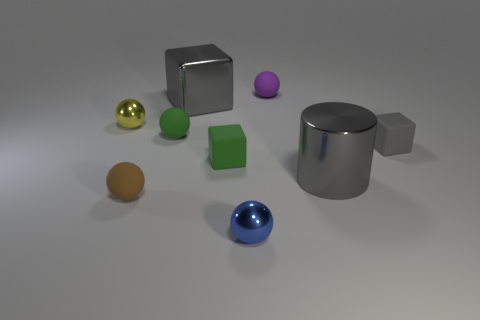Subtract all large shiny blocks. How many blocks are left? 2 Subtract 0 red spheres. How many objects are left? 9 Subtract all cylinders. How many objects are left? 8 Subtract 2 cubes. How many cubes are left? 1 Subtract all gray cubes. Subtract all brown cylinders. How many cubes are left? 1 Subtract all brown cylinders. How many blue balls are left? 1 Subtract all green objects. Subtract all small gray rubber objects. How many objects are left? 6 Add 3 yellow metal things. How many yellow metal things are left? 4 Add 2 small shiny balls. How many small shiny balls exist? 4 Add 1 green things. How many objects exist? 10 